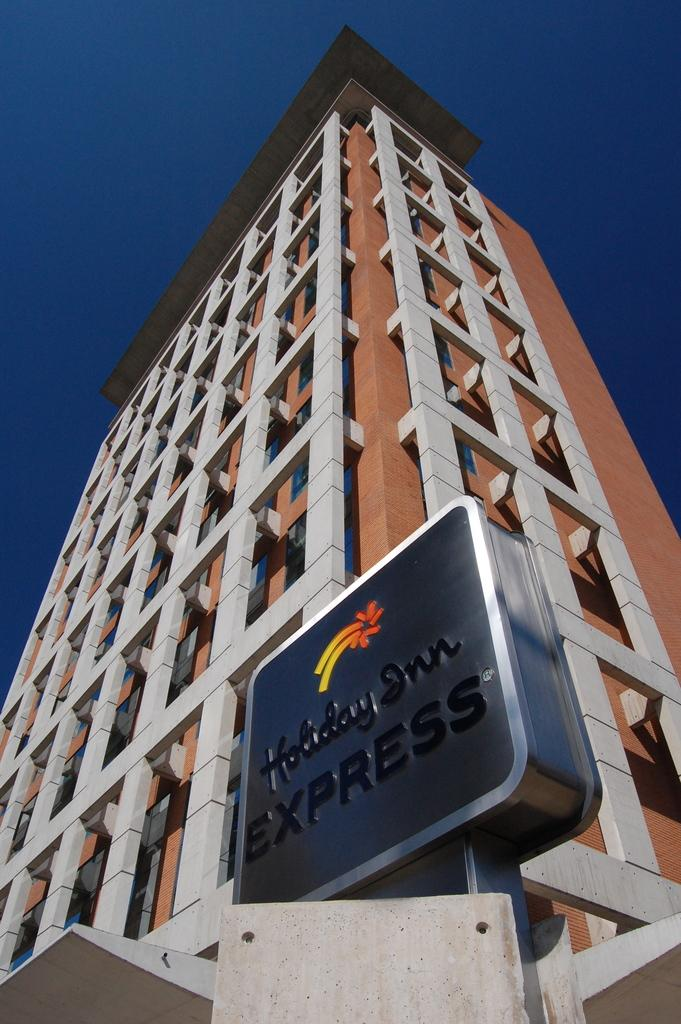What is the main subject of the picture? The main subject of the picture is a building. What is attached to the building? There is a name board on the building. What can be seen in the background of the picture? The sky is visible in the background of the picture. What type of pan can be seen hanging on the wall in the image? There is no pan present in the image; it features a building with a name board. Can you describe the art displayed in the building in the image? The image does not show any art displayed inside the building. 